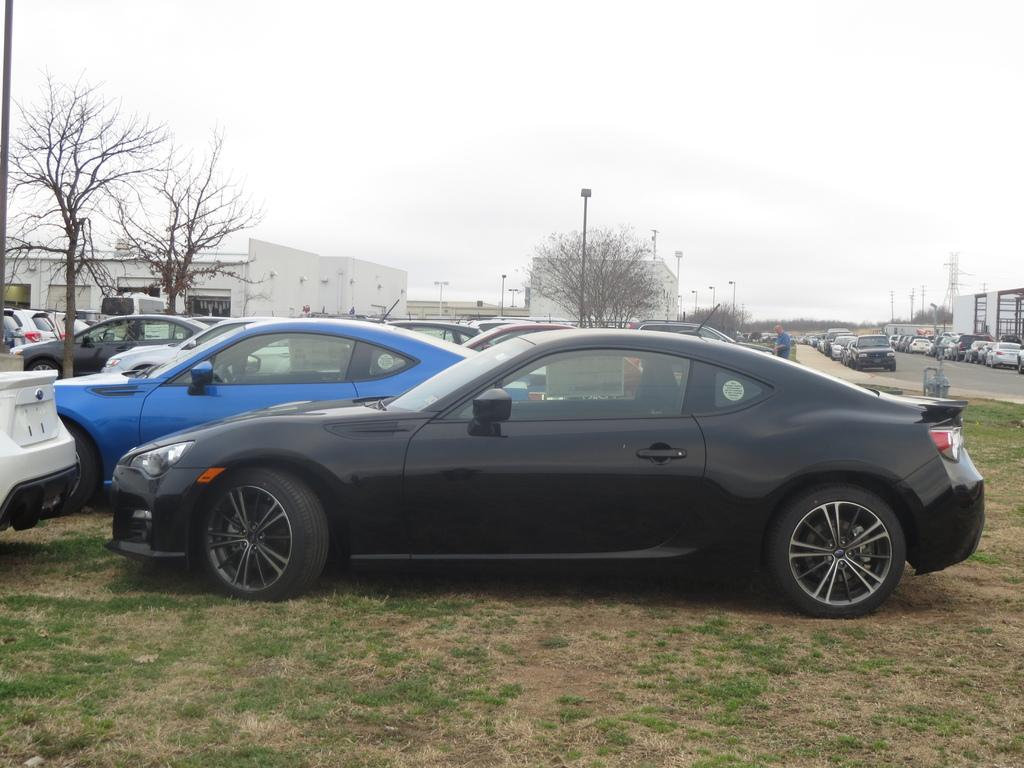What can be seen in the parking area in the image? There are cars parked in a parking area in the image. What is the main feature of the parking area? The main feature of the parking area is the presence of cars. What else can be seen in the image besides the parking area? There is a road, trees, houses, and the sky visible in the background of the image. How many types of structures can be seen in the background? Two types of structures can be seen in the background: trees and houses. What is the belief of the cars in the image? Cars do not have beliefs, as they are inanimate objects. 